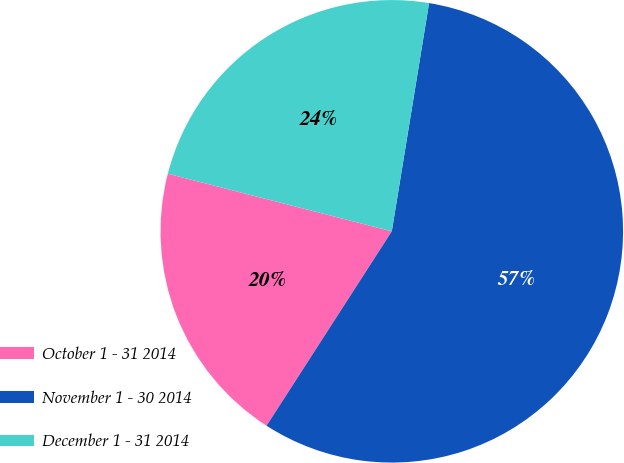Convert chart to OTSL. <chart><loc_0><loc_0><loc_500><loc_500><pie_chart><fcel>October 1 - 31 2014<fcel>November 1 - 30 2014<fcel>December 1 - 31 2014<nl><fcel>19.9%<fcel>56.53%<fcel>23.57%<nl></chart> 